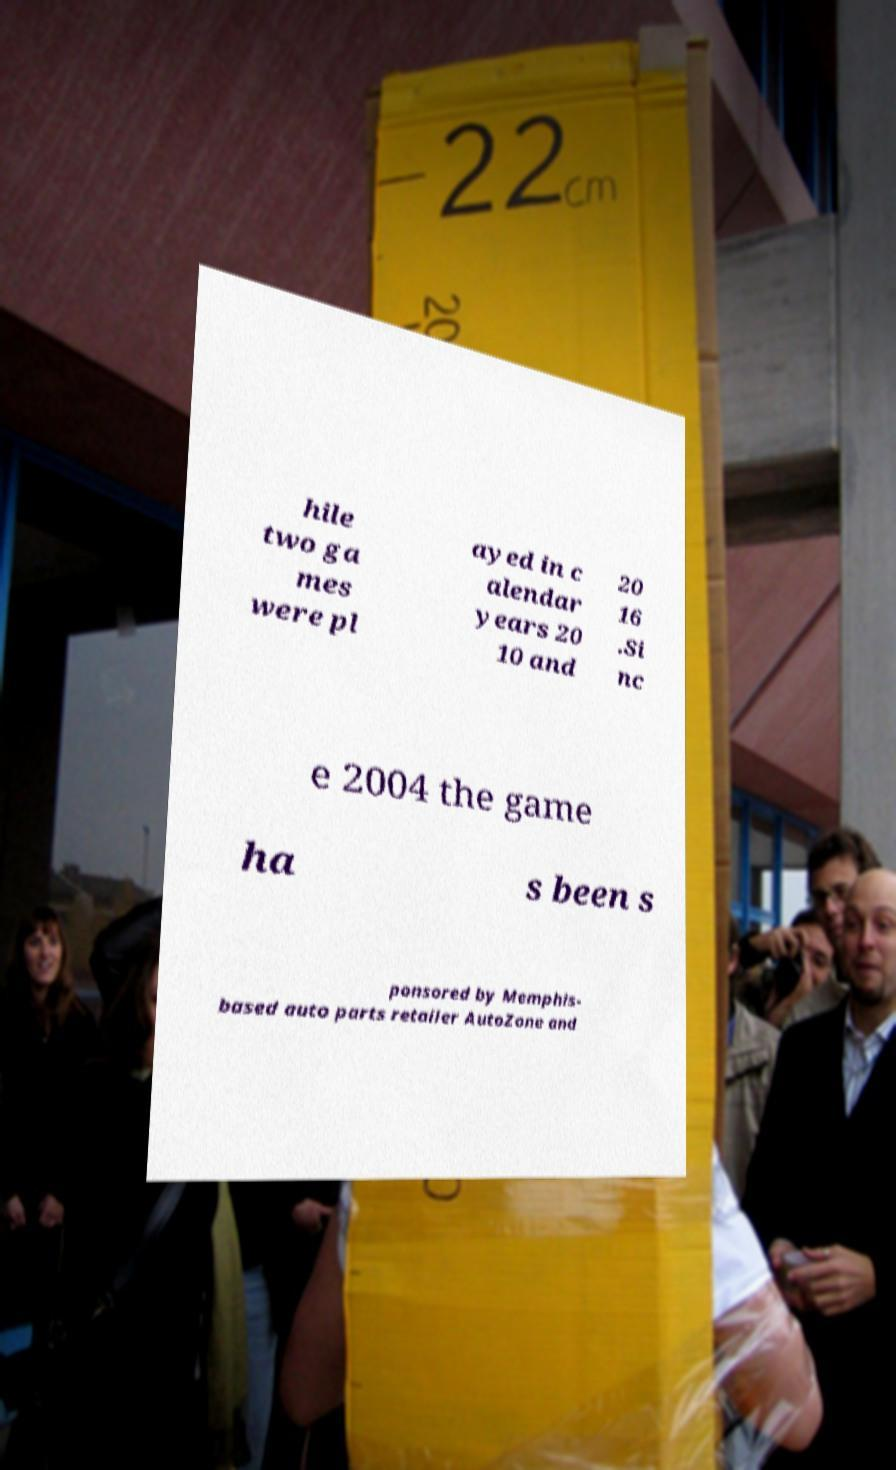I need the written content from this picture converted into text. Can you do that? hile two ga mes were pl ayed in c alendar years 20 10 and 20 16 .Si nc e 2004 the game ha s been s ponsored by Memphis- based auto parts retailer AutoZone and 